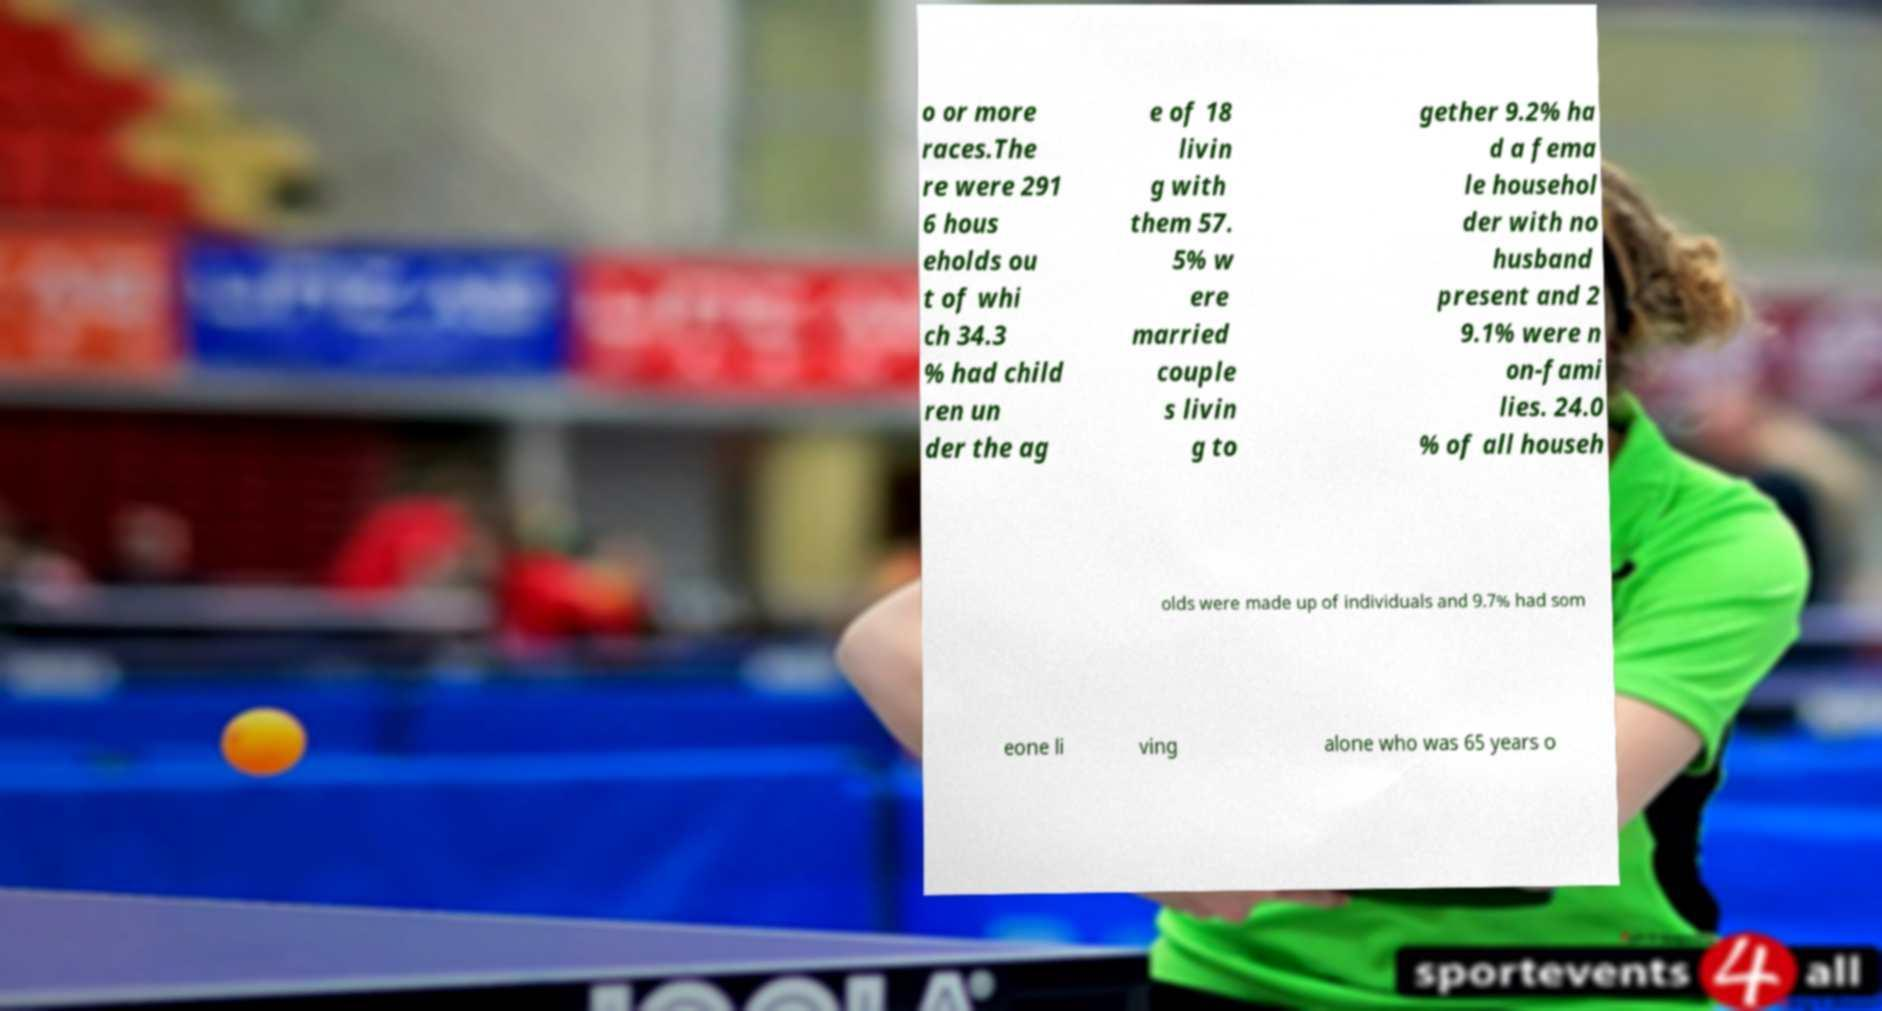Could you extract and type out the text from this image? o or more races.The re were 291 6 hous eholds ou t of whi ch 34.3 % had child ren un der the ag e of 18 livin g with them 57. 5% w ere married couple s livin g to gether 9.2% ha d a fema le househol der with no husband present and 2 9.1% were n on-fami lies. 24.0 % of all househ olds were made up of individuals and 9.7% had som eone li ving alone who was 65 years o 